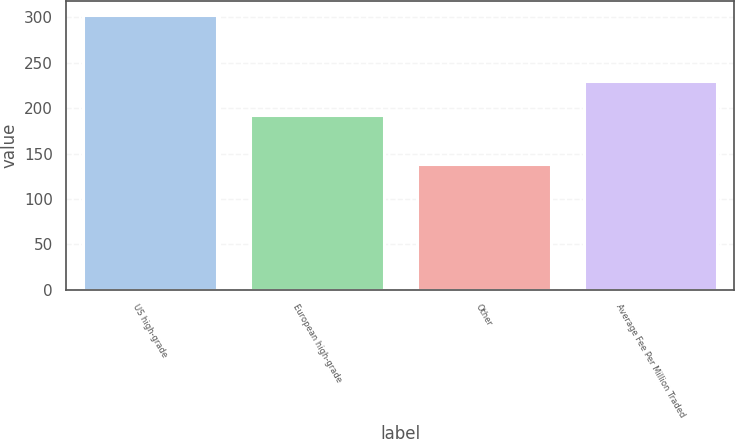Convert chart. <chart><loc_0><loc_0><loc_500><loc_500><bar_chart><fcel>US high-grade<fcel>European high-grade<fcel>Other<fcel>Average Fee Per Million Traded<nl><fcel>303<fcel>193<fcel>138<fcel>230<nl></chart> 